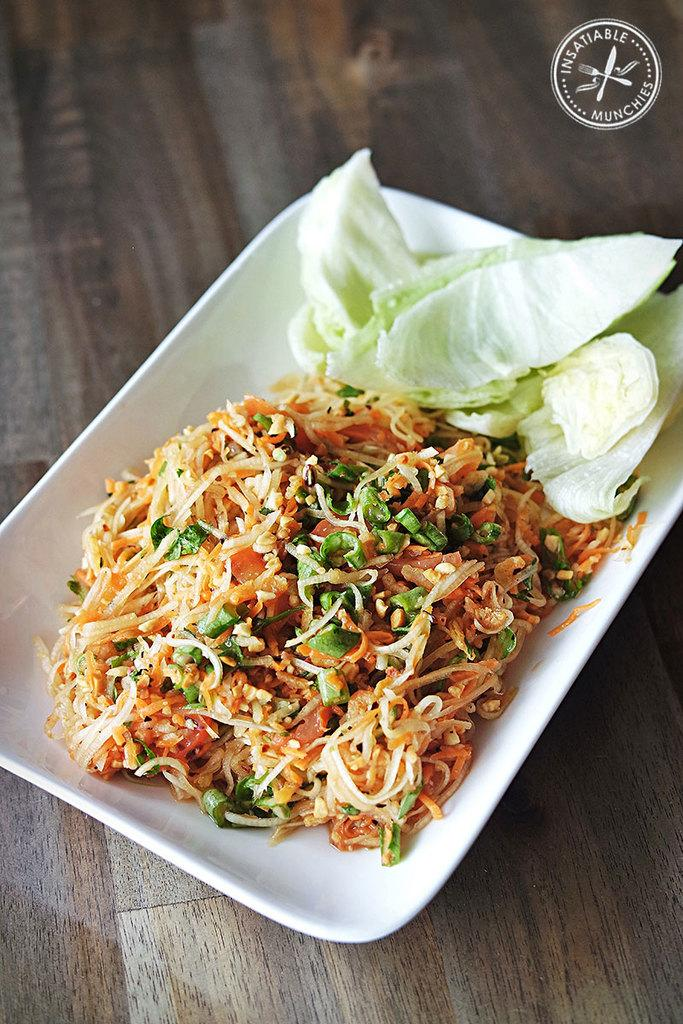What is on the plate that is visible in the image? There is food on a plate in the image. What is the plate resting on? The plate is on a wooden surface. Where is the logo located in the image? The logo is in the top right of the image. What type of wristwatch is the horse wearing in the image? There is no horse or wristwatch present in the image. How is the aunt related to the food on the plate in the image? There is no mention of an aunt in the image, and the relationship between the aunt and the food on the plate cannot be determined. 